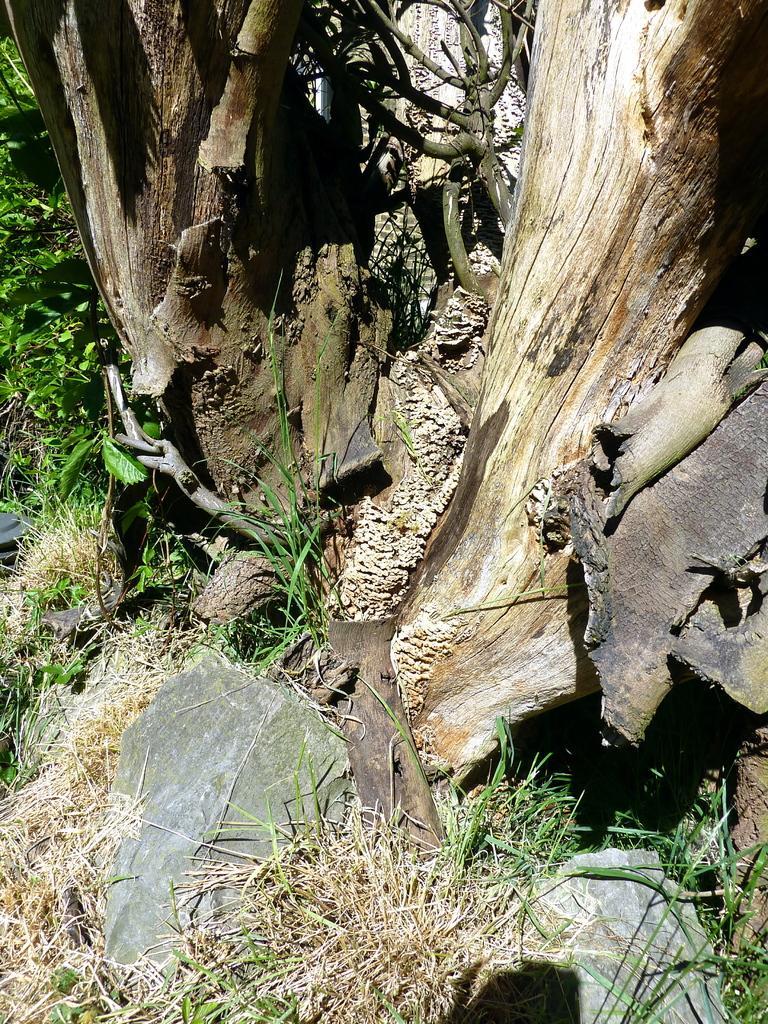How would you summarize this image in a sentence or two? In this picture we can see a tree here, at the bottom there is grass and a rock. 